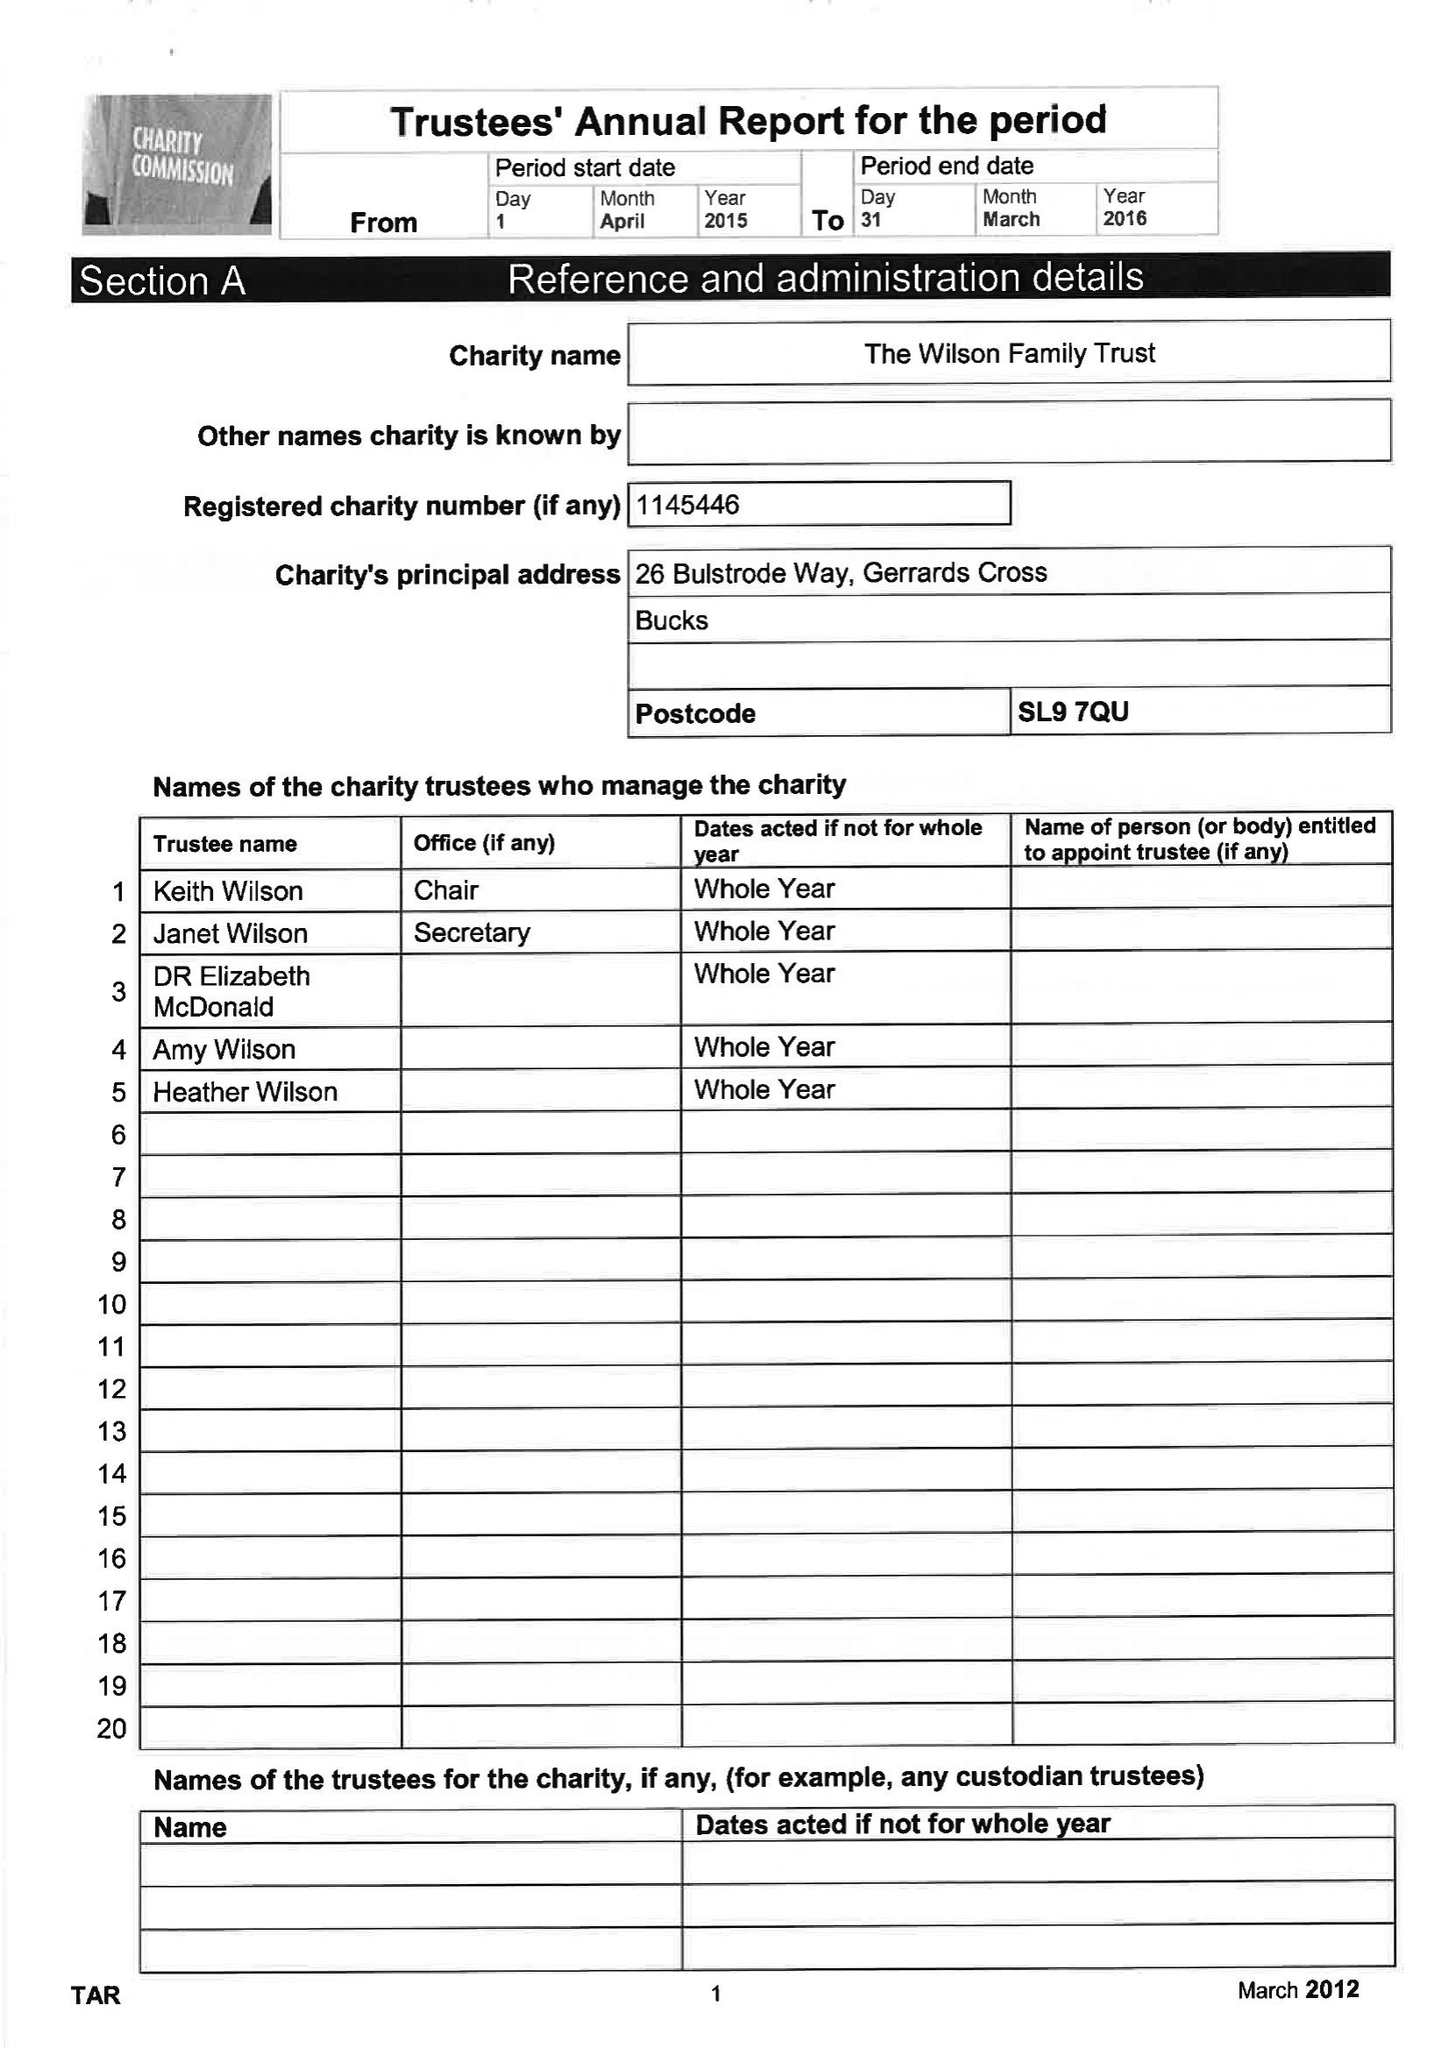What is the value for the address__postcode?
Answer the question using a single word or phrase. SL9 7QU 